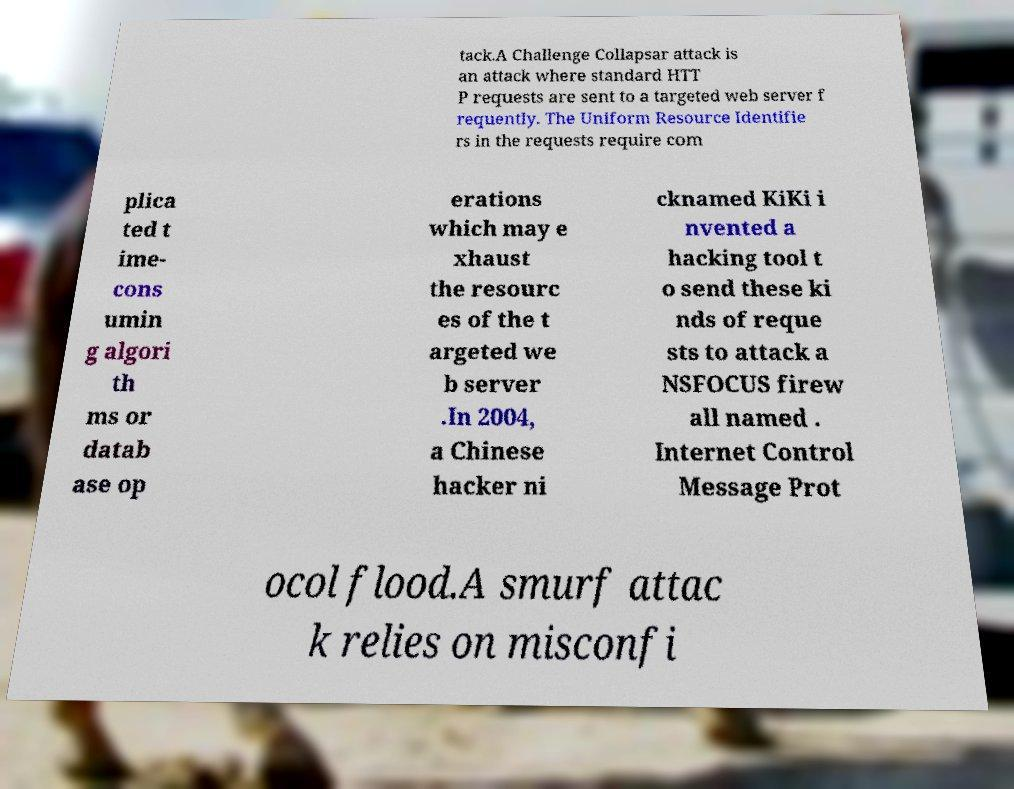Please read and relay the text visible in this image. What does it say? tack.A Challenge Collapsar attack is an attack where standard HTT P requests are sent to a targeted web server f requently. The Uniform Resource Identifie rs in the requests require com plica ted t ime- cons umin g algori th ms or datab ase op erations which may e xhaust the resourc es of the t argeted we b server .In 2004, a Chinese hacker ni cknamed KiKi i nvented a hacking tool t o send these ki nds of reque sts to attack a NSFOCUS firew all named . Internet Control Message Prot ocol flood.A smurf attac k relies on misconfi 